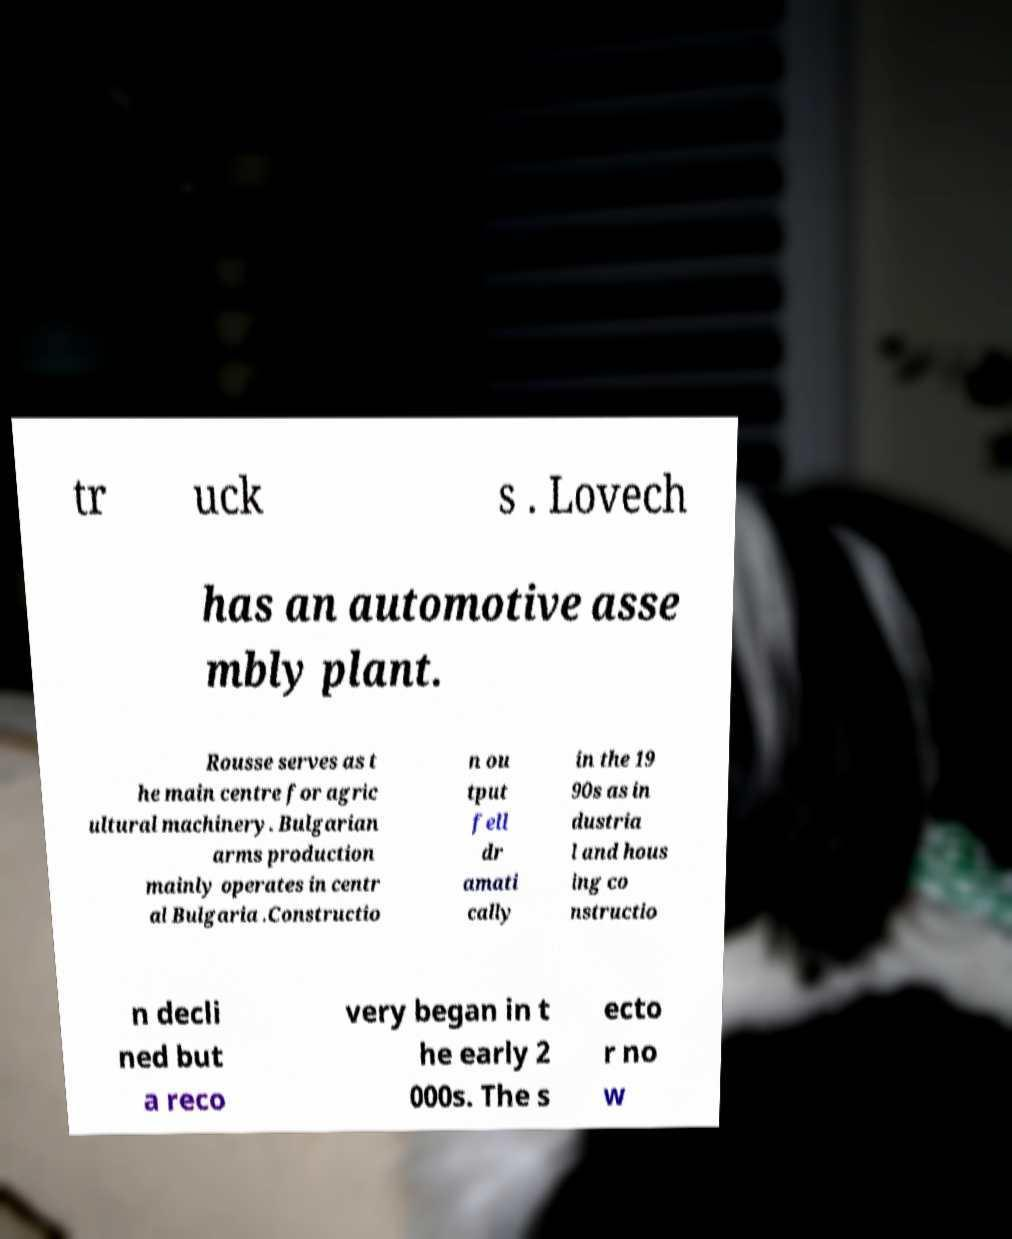For documentation purposes, I need the text within this image transcribed. Could you provide that? tr uck s . Lovech has an automotive asse mbly plant. Rousse serves as t he main centre for agric ultural machinery. Bulgarian arms production mainly operates in centr al Bulgaria .Constructio n ou tput fell dr amati cally in the 19 90s as in dustria l and hous ing co nstructio n decli ned but a reco very began in t he early 2 000s. The s ecto r no w 